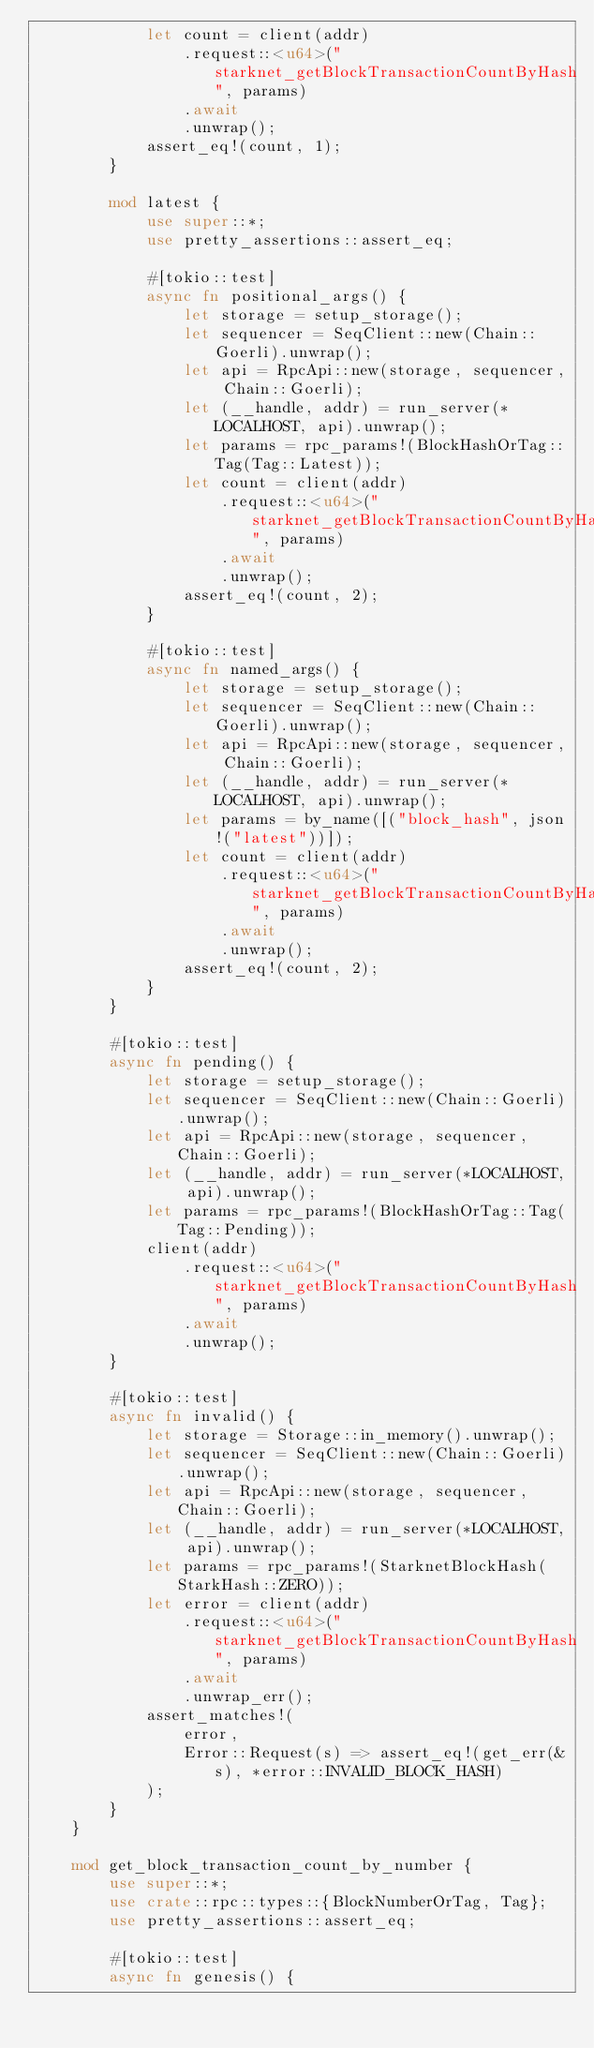Convert code to text. <code><loc_0><loc_0><loc_500><loc_500><_Rust_>            let count = client(addr)
                .request::<u64>("starknet_getBlockTransactionCountByHash", params)
                .await
                .unwrap();
            assert_eq!(count, 1);
        }

        mod latest {
            use super::*;
            use pretty_assertions::assert_eq;

            #[tokio::test]
            async fn positional_args() {
                let storage = setup_storage();
                let sequencer = SeqClient::new(Chain::Goerli).unwrap();
                let api = RpcApi::new(storage, sequencer, Chain::Goerli);
                let (__handle, addr) = run_server(*LOCALHOST, api).unwrap();
                let params = rpc_params!(BlockHashOrTag::Tag(Tag::Latest));
                let count = client(addr)
                    .request::<u64>("starknet_getBlockTransactionCountByHash", params)
                    .await
                    .unwrap();
                assert_eq!(count, 2);
            }

            #[tokio::test]
            async fn named_args() {
                let storage = setup_storage();
                let sequencer = SeqClient::new(Chain::Goerli).unwrap();
                let api = RpcApi::new(storage, sequencer, Chain::Goerli);
                let (__handle, addr) = run_server(*LOCALHOST, api).unwrap();
                let params = by_name([("block_hash", json!("latest"))]);
                let count = client(addr)
                    .request::<u64>("starknet_getBlockTransactionCountByHash", params)
                    .await
                    .unwrap();
                assert_eq!(count, 2);
            }
        }

        #[tokio::test]
        async fn pending() {
            let storage = setup_storage();
            let sequencer = SeqClient::new(Chain::Goerli).unwrap();
            let api = RpcApi::new(storage, sequencer, Chain::Goerli);
            let (__handle, addr) = run_server(*LOCALHOST, api).unwrap();
            let params = rpc_params!(BlockHashOrTag::Tag(Tag::Pending));
            client(addr)
                .request::<u64>("starknet_getBlockTransactionCountByHash", params)
                .await
                .unwrap();
        }

        #[tokio::test]
        async fn invalid() {
            let storage = Storage::in_memory().unwrap();
            let sequencer = SeqClient::new(Chain::Goerli).unwrap();
            let api = RpcApi::new(storage, sequencer, Chain::Goerli);
            let (__handle, addr) = run_server(*LOCALHOST, api).unwrap();
            let params = rpc_params!(StarknetBlockHash(StarkHash::ZERO));
            let error = client(addr)
                .request::<u64>("starknet_getBlockTransactionCountByHash", params)
                .await
                .unwrap_err();
            assert_matches!(
                error,
                Error::Request(s) => assert_eq!(get_err(&s), *error::INVALID_BLOCK_HASH)
            );
        }
    }

    mod get_block_transaction_count_by_number {
        use super::*;
        use crate::rpc::types::{BlockNumberOrTag, Tag};
        use pretty_assertions::assert_eq;

        #[tokio::test]
        async fn genesis() {</code> 